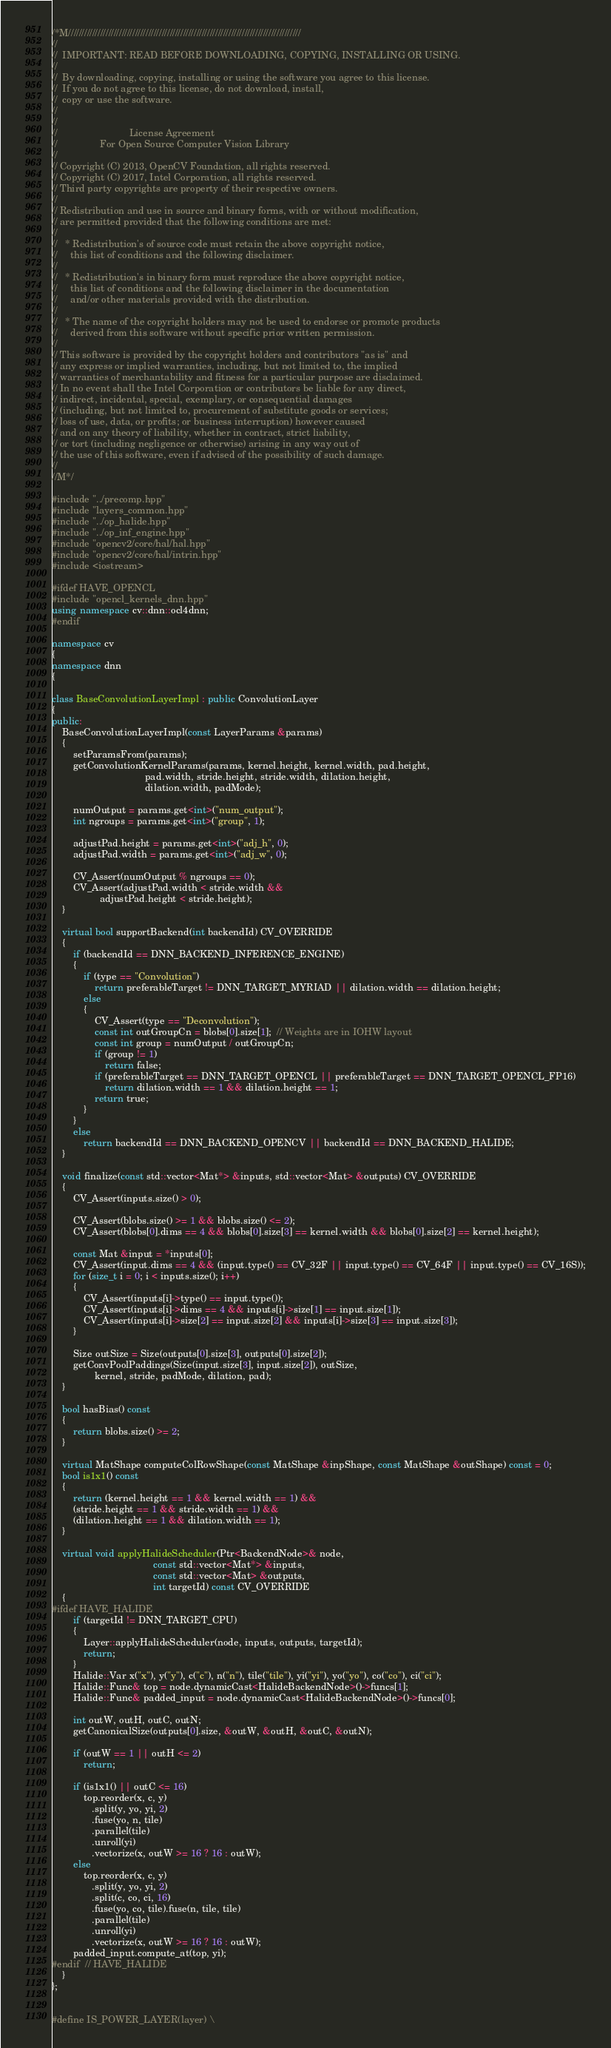Convert code to text. <code><loc_0><loc_0><loc_500><loc_500><_C++_>/*M///////////////////////////////////////////////////////////////////////////////////////
//
//  IMPORTANT: READ BEFORE DOWNLOADING, COPYING, INSTALLING OR USING.
//
//  By downloading, copying, installing or using the software you agree to this license.
//  If you do not agree to this license, do not download, install,
//  copy or use the software.
//
//
//                           License Agreement
//                For Open Source Computer Vision Library
//
// Copyright (C) 2013, OpenCV Foundation, all rights reserved.
// Copyright (C) 2017, Intel Corporation, all rights reserved.
// Third party copyrights are property of their respective owners.
//
// Redistribution and use in source and binary forms, with or without modification,
// are permitted provided that the following conditions are met:
//
//   * Redistribution's of source code must retain the above copyright notice,
//     this list of conditions and the following disclaimer.
//
//   * Redistribution's in binary form must reproduce the above copyright notice,
//     this list of conditions and the following disclaimer in the documentation
//     and/or other materials provided with the distribution.
//
//   * The name of the copyright holders may not be used to endorse or promote products
//     derived from this software without specific prior written permission.
//
// This software is provided by the copyright holders and contributors "as is" and
// any express or implied warranties, including, but not limited to, the implied
// warranties of merchantability and fitness for a particular purpose are disclaimed.
// In no event shall the Intel Corporation or contributors be liable for any direct,
// indirect, incidental, special, exemplary, or consequential damages
// (including, but not limited to, procurement of substitute goods or services;
// loss of use, data, or profits; or business interruption) however caused
// and on any theory of liability, whether in contract, strict liability,
// or tort (including negligence or otherwise) arising in any way out of
// the use of this software, even if advised of the possibility of such damage.
//
//M*/

#include "../precomp.hpp"
#include "layers_common.hpp"
#include "../op_halide.hpp"
#include "../op_inf_engine.hpp"
#include "opencv2/core/hal/hal.hpp"
#include "opencv2/core/hal/intrin.hpp"
#include <iostream>

#ifdef HAVE_OPENCL
#include "opencl_kernels_dnn.hpp"
using namespace cv::dnn::ocl4dnn;
#endif

namespace cv
{
namespace dnn
{

class BaseConvolutionLayerImpl : public ConvolutionLayer
{
public:
    BaseConvolutionLayerImpl(const LayerParams &params)
    {
        setParamsFrom(params);
        getConvolutionKernelParams(params, kernel.height, kernel.width, pad.height,
                                   pad.width, stride.height, stride.width, dilation.height,
                                   dilation.width, padMode);

        numOutput = params.get<int>("num_output");
        int ngroups = params.get<int>("group", 1);

        adjustPad.height = params.get<int>("adj_h", 0);
        adjustPad.width = params.get<int>("adj_w", 0);

        CV_Assert(numOutput % ngroups == 0);
        CV_Assert(adjustPad.width < stride.width &&
                  adjustPad.height < stride.height);
    }

    virtual bool supportBackend(int backendId) CV_OVERRIDE
    {
        if (backendId == DNN_BACKEND_INFERENCE_ENGINE)
        {
            if (type == "Convolution")
                return preferableTarget != DNN_TARGET_MYRIAD || dilation.width == dilation.height;
            else
            {
                CV_Assert(type == "Deconvolution");
                const int outGroupCn = blobs[0].size[1];  // Weights are in IOHW layout
                const int group = numOutput / outGroupCn;
                if (group != 1)
                    return false;
                if (preferableTarget == DNN_TARGET_OPENCL || preferableTarget == DNN_TARGET_OPENCL_FP16)
                    return dilation.width == 1 && dilation.height == 1;
                return true;
            }
        }
        else
            return backendId == DNN_BACKEND_OPENCV || backendId == DNN_BACKEND_HALIDE;
    }

    void finalize(const std::vector<Mat*> &inputs, std::vector<Mat> &outputs) CV_OVERRIDE
    {
        CV_Assert(inputs.size() > 0);

        CV_Assert(blobs.size() >= 1 && blobs.size() <= 2);
        CV_Assert(blobs[0].dims == 4 && blobs[0].size[3] == kernel.width && blobs[0].size[2] == kernel.height);

        const Mat &input = *inputs[0];
        CV_Assert(input.dims == 4 && (input.type() == CV_32F || input.type() == CV_64F || input.type() == CV_16S));
        for (size_t i = 0; i < inputs.size(); i++)
        {
            CV_Assert(inputs[i]->type() == input.type());
            CV_Assert(inputs[i]->dims == 4 && inputs[i]->size[1] == input.size[1]);
            CV_Assert(inputs[i]->size[2] == input.size[2] && inputs[i]->size[3] == input.size[3]);
        }

        Size outSize = Size(outputs[0].size[3], outputs[0].size[2]);
        getConvPoolPaddings(Size(input.size[3], input.size[2]), outSize,
                kernel, stride, padMode, dilation, pad);
    }

    bool hasBias() const
    {
        return blobs.size() >= 2;
    }

    virtual MatShape computeColRowShape(const MatShape &inpShape, const MatShape &outShape) const = 0;
    bool is1x1() const
    {
        return (kernel.height == 1 && kernel.width == 1) &&
        (stride.height == 1 && stride.width == 1) &&
        (dilation.height == 1 && dilation.width == 1);
    }

    virtual void applyHalideScheduler(Ptr<BackendNode>& node,
                                      const std::vector<Mat*> &inputs,
                                      const std::vector<Mat> &outputs,
                                      int targetId) const CV_OVERRIDE
    {
#ifdef HAVE_HALIDE
        if (targetId != DNN_TARGET_CPU)
        {
            Layer::applyHalideScheduler(node, inputs, outputs, targetId);
            return;
        }
        Halide::Var x("x"), y("y"), c("c"), n("n"), tile("tile"), yi("yi"), yo("yo"), co("co"), ci("ci");
        Halide::Func& top = node.dynamicCast<HalideBackendNode>()->funcs[1];
        Halide::Func& padded_input = node.dynamicCast<HalideBackendNode>()->funcs[0];

        int outW, outH, outC, outN;
        getCanonicalSize(outputs[0].size, &outW, &outH, &outC, &outN);

        if (outW == 1 || outH <= 2)
            return;

        if (is1x1() || outC <= 16)
            top.reorder(x, c, y)
               .split(y, yo, yi, 2)
               .fuse(yo, n, tile)
               .parallel(tile)
               .unroll(yi)
               .vectorize(x, outW >= 16 ? 16 : outW);
        else
            top.reorder(x, c, y)
               .split(y, yo, yi, 2)
               .split(c, co, ci, 16)
               .fuse(yo, co, tile).fuse(n, tile, tile)
               .parallel(tile)
               .unroll(yi)
               .vectorize(x, outW >= 16 ? 16 : outW);
        padded_input.compute_at(top, yi);
#endif  // HAVE_HALIDE
    }
};


#define IS_POWER_LAYER(layer) \</code> 